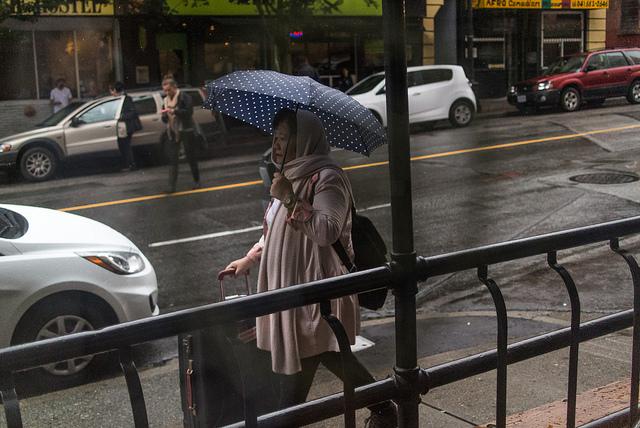What color is the umbrella?
Be succinct. Blue. What is in the lady's hand which is not holding an umbrella?
Quick response, please. Suitcase. Are the streets wet in this picture?
Concise answer only. Yes. Is a woman crossing the street?
Quick response, please. Yes. What is the person gender with the umbrella?
Concise answer only. Female. 